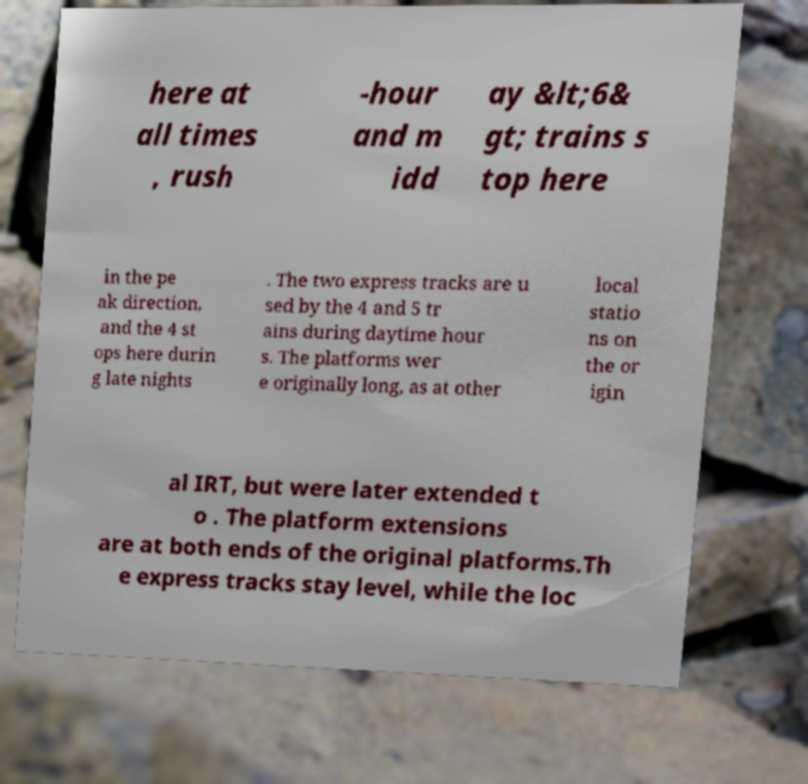For documentation purposes, I need the text within this image transcribed. Could you provide that? here at all times , rush -hour and m idd ay &lt;6& gt; trains s top here in the pe ak direction, and the 4 st ops here durin g late nights . The two express tracks are u sed by the 4 and 5 tr ains during daytime hour s. The platforms wer e originally long, as at other local statio ns on the or igin al IRT, but were later extended t o . The platform extensions are at both ends of the original platforms.Th e express tracks stay level, while the loc 